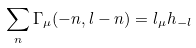Convert formula to latex. <formula><loc_0><loc_0><loc_500><loc_500>\sum _ { n } \Gamma _ { \mu } ( - n , l - n ) = l _ { \mu } h _ { - l }</formula> 